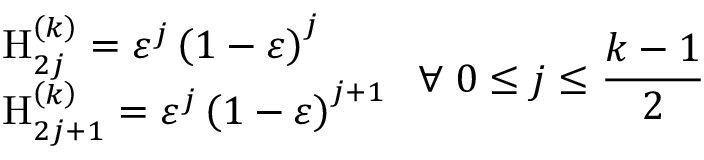<formula> <loc_0><loc_0><loc_500><loc_500>\begin{array} { l } { { H _ { 2 j } ^ { \left ( k \right ) } = \varepsilon ^ { j } \left ( 1 - \varepsilon \right ) ^ { j } } } \\ { { H _ { 2 j + 1 } ^ { \left ( k \right ) } = \varepsilon ^ { j } \left ( 1 - \varepsilon \right ) ^ { j + 1 } } } \end{array} \, \forall \, 0 \leq j \leq \frac { k - 1 } 2</formula> 